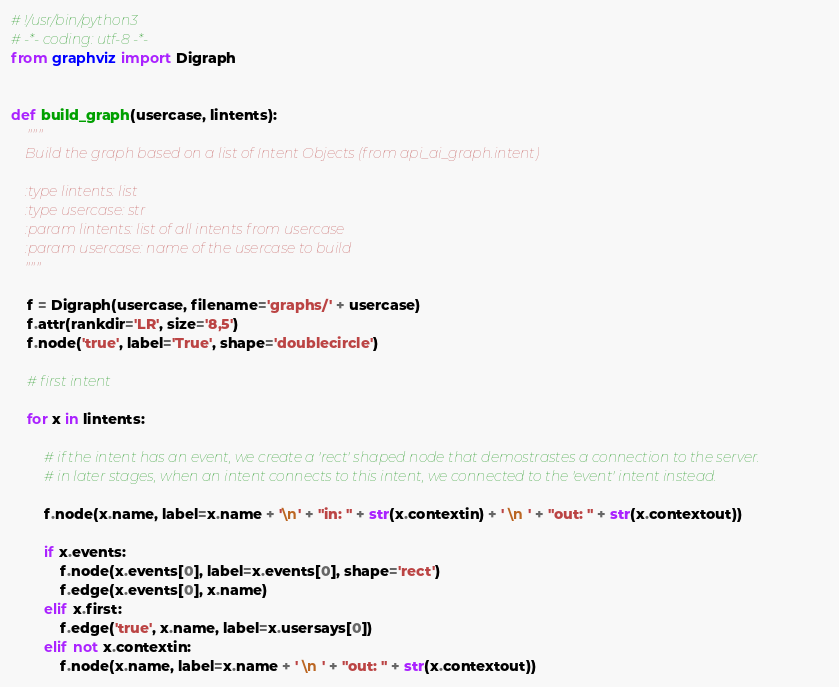<code> <loc_0><loc_0><loc_500><loc_500><_Python_># !/usr/bin/python3
# -*- coding: utf-8 -*-
from graphviz import Digraph


def build_graph(usercase, lintents):
	"""
	Build the graph based on a list of Intent Objects (from api_ai_graph.intent)

	:type lintents: list
	:type usercase: str
	:param lintents: list of all intents from usercase
	:param usercase: name of the usercase to build
	"""

	f = Digraph(usercase, filename='graphs/' + usercase)
	f.attr(rankdir='LR', size='8,5')
	f.node('true', label='True', shape='doublecircle')

	# first intent

	for x in lintents:

		# if the intent has an event, we create a 'rect' shaped node that demostrastes a connection to the server.
		# in later stages, when an intent connects to this intent, we connected to the 'event' intent instead.

		f.node(x.name, label=x.name + '\n' + "in: " + str(x.contextin) + ' \n ' + "out: " + str(x.contextout))

		if x.events:
			f.node(x.events[0], label=x.events[0], shape='rect')
			f.edge(x.events[0], x.name)
		elif x.first:
			f.edge('true', x.name, label=x.usersays[0])
		elif not x.contextin:
			f.node(x.name, label=x.name + ' \n ' + "out: " + str(x.contextout))</code> 